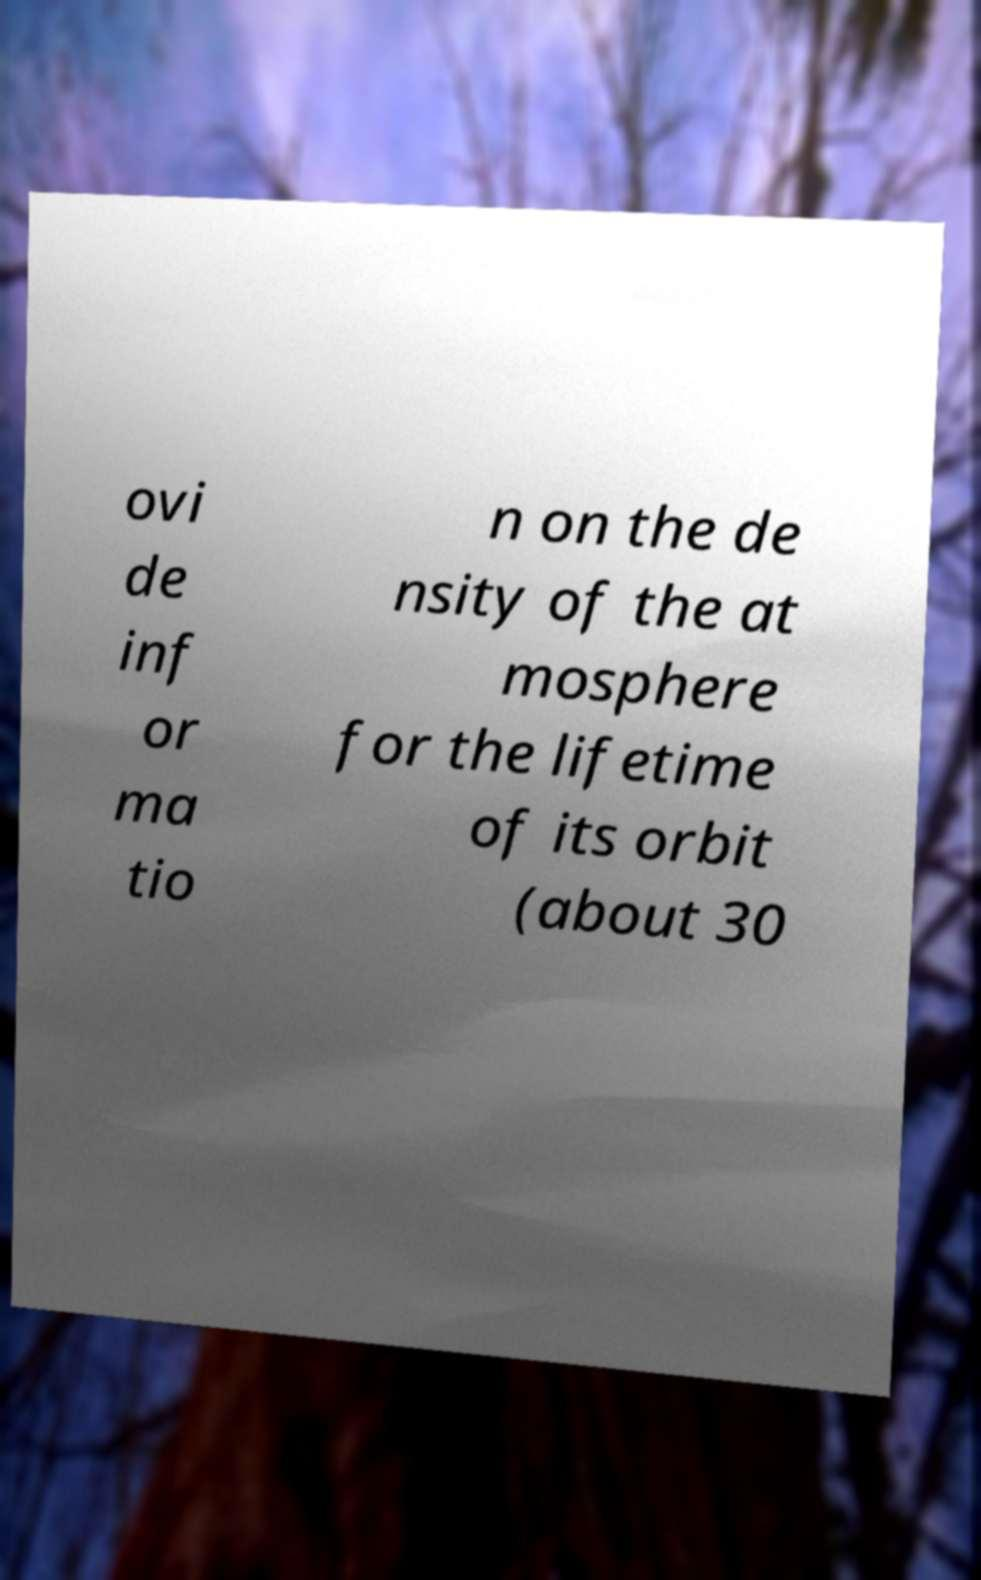There's text embedded in this image that I need extracted. Can you transcribe it verbatim? ovi de inf or ma tio n on the de nsity of the at mosphere for the lifetime of its orbit (about 30 